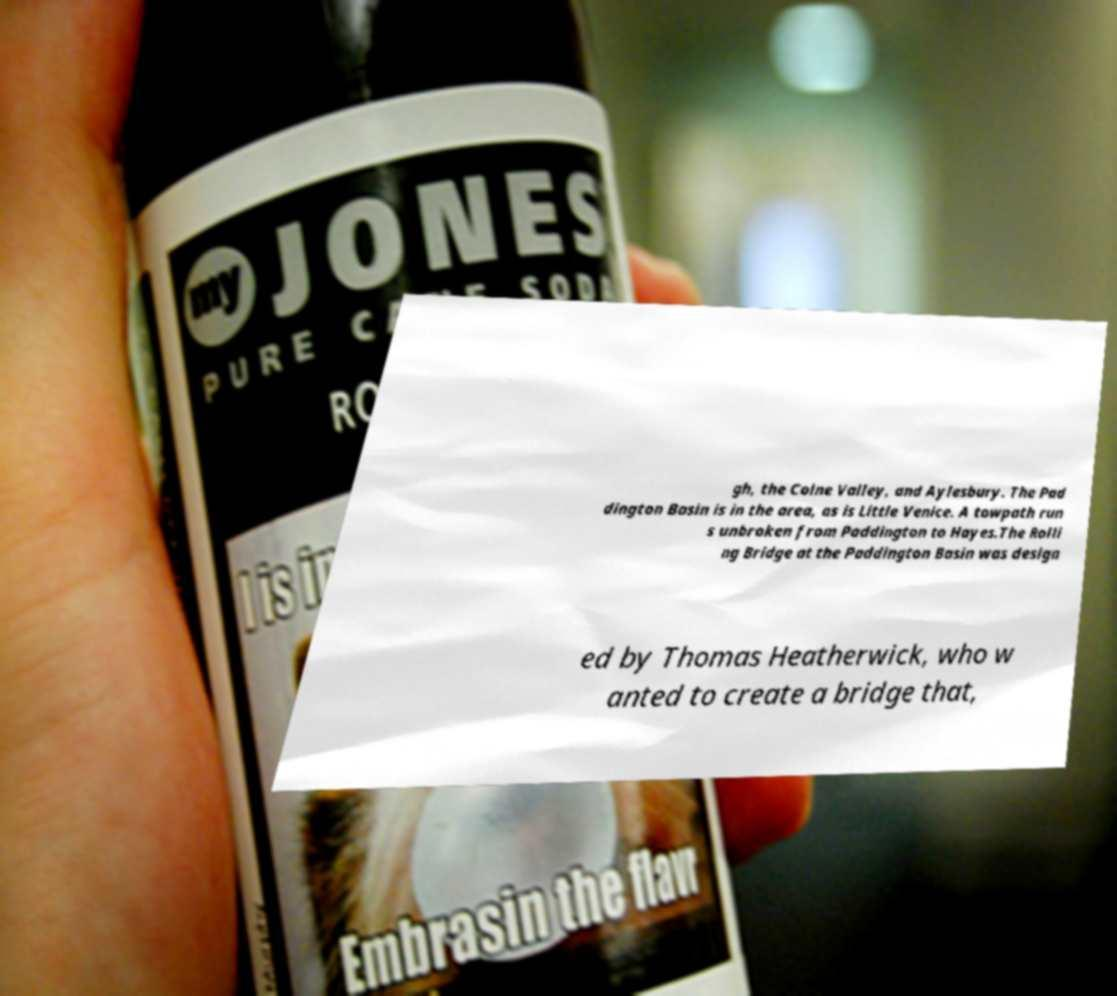Please identify and transcribe the text found in this image. gh, the Colne Valley, and Aylesbury. The Pad dington Basin is in the area, as is Little Venice. A towpath run s unbroken from Paddington to Hayes.The Rolli ng Bridge at the Paddington Basin was design ed by Thomas Heatherwick, who w anted to create a bridge that, 